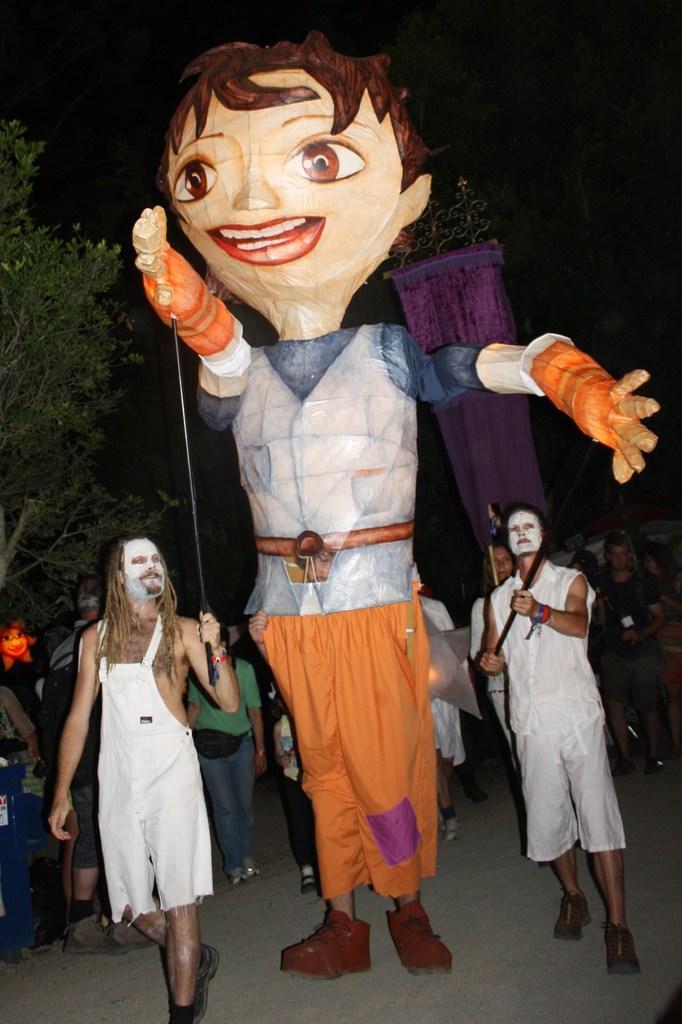Can you describe this image briefly? In the center of the image a clown is there. In the background of the image some persons are standing. On the left side of the image a tree is there. At the bottom of the image ground is present. 